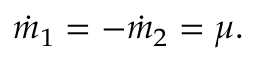Convert formula to latex. <formula><loc_0><loc_0><loc_500><loc_500>\dot { m } _ { 1 } = - \dot { m } _ { 2 } = \mu .</formula> 